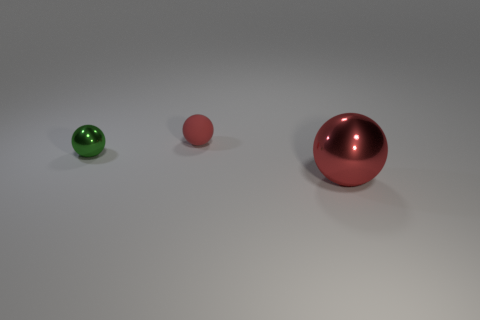Subtract all red balls. How many were subtracted if there are1red balls left? 1 Subtract all matte spheres. How many spheres are left? 2 Add 1 tiny brown matte cylinders. How many objects exist? 4 Subtract all brown cylinders. How many red balls are left? 2 Subtract all green balls. How many balls are left? 2 Subtract 3 spheres. How many spheres are left? 0 Subtract all large red cubes. Subtract all red balls. How many objects are left? 1 Add 2 big balls. How many big balls are left? 3 Add 2 large yellow objects. How many large yellow objects exist? 2 Subtract 0 gray blocks. How many objects are left? 3 